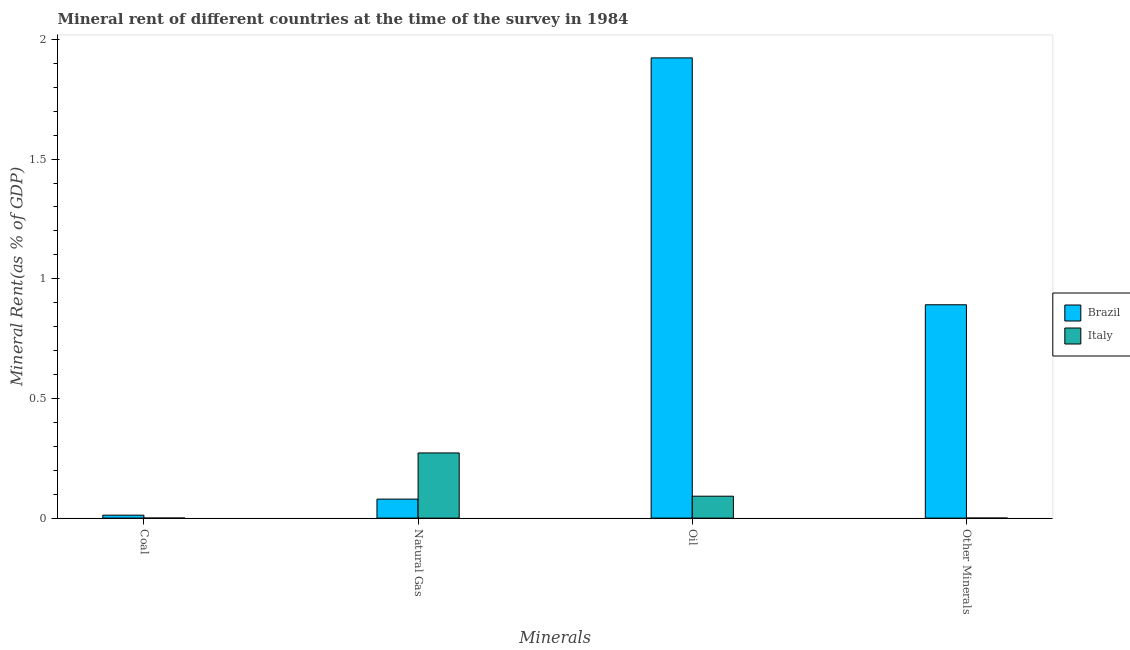How many different coloured bars are there?
Make the answer very short. 2. How many groups of bars are there?
Provide a succinct answer. 4. Are the number of bars per tick equal to the number of legend labels?
Offer a terse response. Yes. Are the number of bars on each tick of the X-axis equal?
Give a very brief answer. Yes. How many bars are there on the 1st tick from the right?
Offer a very short reply. 2. What is the label of the 1st group of bars from the left?
Your answer should be compact. Coal. What is the oil rent in Italy?
Your answer should be very brief. 0.09. Across all countries, what is the maximum oil rent?
Your response must be concise. 1.92. Across all countries, what is the minimum natural gas rent?
Your answer should be very brief. 0.08. What is the total oil rent in the graph?
Ensure brevity in your answer.  2.01. What is the difference between the oil rent in Brazil and that in Italy?
Make the answer very short. 1.83. What is the difference between the coal rent in Italy and the oil rent in Brazil?
Offer a terse response. -1.92. What is the average oil rent per country?
Provide a short and direct response. 1.01. What is the difference between the  rent of other minerals and oil rent in Italy?
Make the answer very short. -0.09. What is the ratio of the oil rent in Italy to that in Brazil?
Your answer should be compact. 0.05. Is the difference between the natural gas rent in Italy and Brazil greater than the difference between the  rent of other minerals in Italy and Brazil?
Give a very brief answer. Yes. What is the difference between the highest and the second highest  rent of other minerals?
Your response must be concise. 0.89. What is the difference between the highest and the lowest natural gas rent?
Provide a succinct answer. 0.19. In how many countries, is the coal rent greater than the average coal rent taken over all countries?
Your response must be concise. 1. Is the sum of the  rent of other minerals in Italy and Brazil greater than the maximum oil rent across all countries?
Your answer should be very brief. No. Is it the case that in every country, the sum of the oil rent and natural gas rent is greater than the sum of coal rent and  rent of other minerals?
Offer a terse response. No. Are all the bars in the graph horizontal?
Ensure brevity in your answer.  No. How many countries are there in the graph?
Your answer should be compact. 2. What is the difference between two consecutive major ticks on the Y-axis?
Your answer should be very brief. 0.5. Does the graph contain any zero values?
Offer a very short reply. No. Does the graph contain grids?
Make the answer very short. No. Where does the legend appear in the graph?
Make the answer very short. Center right. What is the title of the graph?
Make the answer very short. Mineral rent of different countries at the time of the survey in 1984. Does "Guyana" appear as one of the legend labels in the graph?
Your answer should be compact. No. What is the label or title of the X-axis?
Keep it short and to the point. Minerals. What is the label or title of the Y-axis?
Provide a short and direct response. Mineral Rent(as % of GDP). What is the Mineral Rent(as % of GDP) of Brazil in Coal?
Your response must be concise. 0.01. What is the Mineral Rent(as % of GDP) of Italy in Coal?
Offer a terse response. 0. What is the Mineral Rent(as % of GDP) of Brazil in Natural Gas?
Keep it short and to the point. 0.08. What is the Mineral Rent(as % of GDP) in Italy in Natural Gas?
Ensure brevity in your answer.  0.27. What is the Mineral Rent(as % of GDP) of Brazil in Oil?
Ensure brevity in your answer.  1.92. What is the Mineral Rent(as % of GDP) of Italy in Oil?
Make the answer very short. 0.09. What is the Mineral Rent(as % of GDP) of Brazil in Other Minerals?
Make the answer very short. 0.89. What is the Mineral Rent(as % of GDP) in Italy in Other Minerals?
Make the answer very short. 0. Across all Minerals, what is the maximum Mineral Rent(as % of GDP) in Brazil?
Your answer should be very brief. 1.92. Across all Minerals, what is the maximum Mineral Rent(as % of GDP) of Italy?
Make the answer very short. 0.27. Across all Minerals, what is the minimum Mineral Rent(as % of GDP) of Brazil?
Keep it short and to the point. 0.01. Across all Minerals, what is the minimum Mineral Rent(as % of GDP) in Italy?
Give a very brief answer. 0. What is the total Mineral Rent(as % of GDP) of Brazil in the graph?
Offer a very short reply. 2.91. What is the total Mineral Rent(as % of GDP) of Italy in the graph?
Provide a short and direct response. 0.36. What is the difference between the Mineral Rent(as % of GDP) of Brazil in Coal and that in Natural Gas?
Make the answer very short. -0.07. What is the difference between the Mineral Rent(as % of GDP) of Italy in Coal and that in Natural Gas?
Offer a terse response. -0.27. What is the difference between the Mineral Rent(as % of GDP) in Brazil in Coal and that in Oil?
Your response must be concise. -1.91. What is the difference between the Mineral Rent(as % of GDP) of Italy in Coal and that in Oil?
Offer a very short reply. -0.09. What is the difference between the Mineral Rent(as % of GDP) of Brazil in Coal and that in Other Minerals?
Make the answer very short. -0.88. What is the difference between the Mineral Rent(as % of GDP) in Italy in Coal and that in Other Minerals?
Keep it short and to the point. -0. What is the difference between the Mineral Rent(as % of GDP) of Brazil in Natural Gas and that in Oil?
Make the answer very short. -1.84. What is the difference between the Mineral Rent(as % of GDP) in Italy in Natural Gas and that in Oil?
Provide a succinct answer. 0.18. What is the difference between the Mineral Rent(as % of GDP) in Brazil in Natural Gas and that in Other Minerals?
Make the answer very short. -0.81. What is the difference between the Mineral Rent(as % of GDP) of Italy in Natural Gas and that in Other Minerals?
Keep it short and to the point. 0.27. What is the difference between the Mineral Rent(as % of GDP) in Brazil in Oil and that in Other Minerals?
Provide a short and direct response. 1.03. What is the difference between the Mineral Rent(as % of GDP) in Italy in Oil and that in Other Minerals?
Give a very brief answer. 0.09. What is the difference between the Mineral Rent(as % of GDP) of Brazil in Coal and the Mineral Rent(as % of GDP) of Italy in Natural Gas?
Offer a very short reply. -0.26. What is the difference between the Mineral Rent(as % of GDP) of Brazil in Coal and the Mineral Rent(as % of GDP) of Italy in Oil?
Offer a terse response. -0.08. What is the difference between the Mineral Rent(as % of GDP) in Brazil in Coal and the Mineral Rent(as % of GDP) in Italy in Other Minerals?
Provide a succinct answer. 0.01. What is the difference between the Mineral Rent(as % of GDP) in Brazil in Natural Gas and the Mineral Rent(as % of GDP) in Italy in Oil?
Make the answer very short. -0.01. What is the difference between the Mineral Rent(as % of GDP) of Brazil in Natural Gas and the Mineral Rent(as % of GDP) of Italy in Other Minerals?
Keep it short and to the point. 0.08. What is the difference between the Mineral Rent(as % of GDP) in Brazil in Oil and the Mineral Rent(as % of GDP) in Italy in Other Minerals?
Provide a succinct answer. 1.92. What is the average Mineral Rent(as % of GDP) in Brazil per Minerals?
Give a very brief answer. 0.73. What is the average Mineral Rent(as % of GDP) in Italy per Minerals?
Your answer should be compact. 0.09. What is the difference between the Mineral Rent(as % of GDP) in Brazil and Mineral Rent(as % of GDP) in Italy in Coal?
Make the answer very short. 0.01. What is the difference between the Mineral Rent(as % of GDP) of Brazil and Mineral Rent(as % of GDP) of Italy in Natural Gas?
Your response must be concise. -0.19. What is the difference between the Mineral Rent(as % of GDP) in Brazil and Mineral Rent(as % of GDP) in Italy in Oil?
Your answer should be compact. 1.83. What is the difference between the Mineral Rent(as % of GDP) of Brazil and Mineral Rent(as % of GDP) of Italy in Other Minerals?
Keep it short and to the point. 0.89. What is the ratio of the Mineral Rent(as % of GDP) in Brazil in Coal to that in Natural Gas?
Offer a terse response. 0.16. What is the ratio of the Mineral Rent(as % of GDP) of Italy in Coal to that in Natural Gas?
Give a very brief answer. 0. What is the ratio of the Mineral Rent(as % of GDP) of Brazil in Coal to that in Oil?
Your answer should be compact. 0.01. What is the ratio of the Mineral Rent(as % of GDP) in Italy in Coal to that in Oil?
Your response must be concise. 0. What is the ratio of the Mineral Rent(as % of GDP) of Brazil in Coal to that in Other Minerals?
Offer a terse response. 0.01. What is the ratio of the Mineral Rent(as % of GDP) in Italy in Coal to that in Other Minerals?
Keep it short and to the point. 0.8. What is the ratio of the Mineral Rent(as % of GDP) in Brazil in Natural Gas to that in Oil?
Provide a short and direct response. 0.04. What is the ratio of the Mineral Rent(as % of GDP) of Italy in Natural Gas to that in Oil?
Offer a terse response. 2.97. What is the ratio of the Mineral Rent(as % of GDP) of Brazil in Natural Gas to that in Other Minerals?
Provide a short and direct response. 0.09. What is the ratio of the Mineral Rent(as % of GDP) in Italy in Natural Gas to that in Other Minerals?
Provide a short and direct response. 1777.57. What is the ratio of the Mineral Rent(as % of GDP) of Brazil in Oil to that in Other Minerals?
Give a very brief answer. 2.16. What is the ratio of the Mineral Rent(as % of GDP) of Italy in Oil to that in Other Minerals?
Keep it short and to the point. 597.78. What is the difference between the highest and the second highest Mineral Rent(as % of GDP) of Brazil?
Your response must be concise. 1.03. What is the difference between the highest and the second highest Mineral Rent(as % of GDP) of Italy?
Keep it short and to the point. 0.18. What is the difference between the highest and the lowest Mineral Rent(as % of GDP) of Brazil?
Your answer should be compact. 1.91. What is the difference between the highest and the lowest Mineral Rent(as % of GDP) of Italy?
Your answer should be compact. 0.27. 